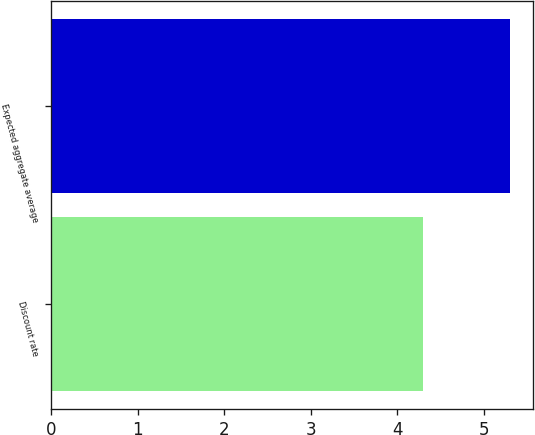<chart> <loc_0><loc_0><loc_500><loc_500><bar_chart><fcel>Discount rate<fcel>Expected aggregate average<nl><fcel>4.3<fcel>5.3<nl></chart> 